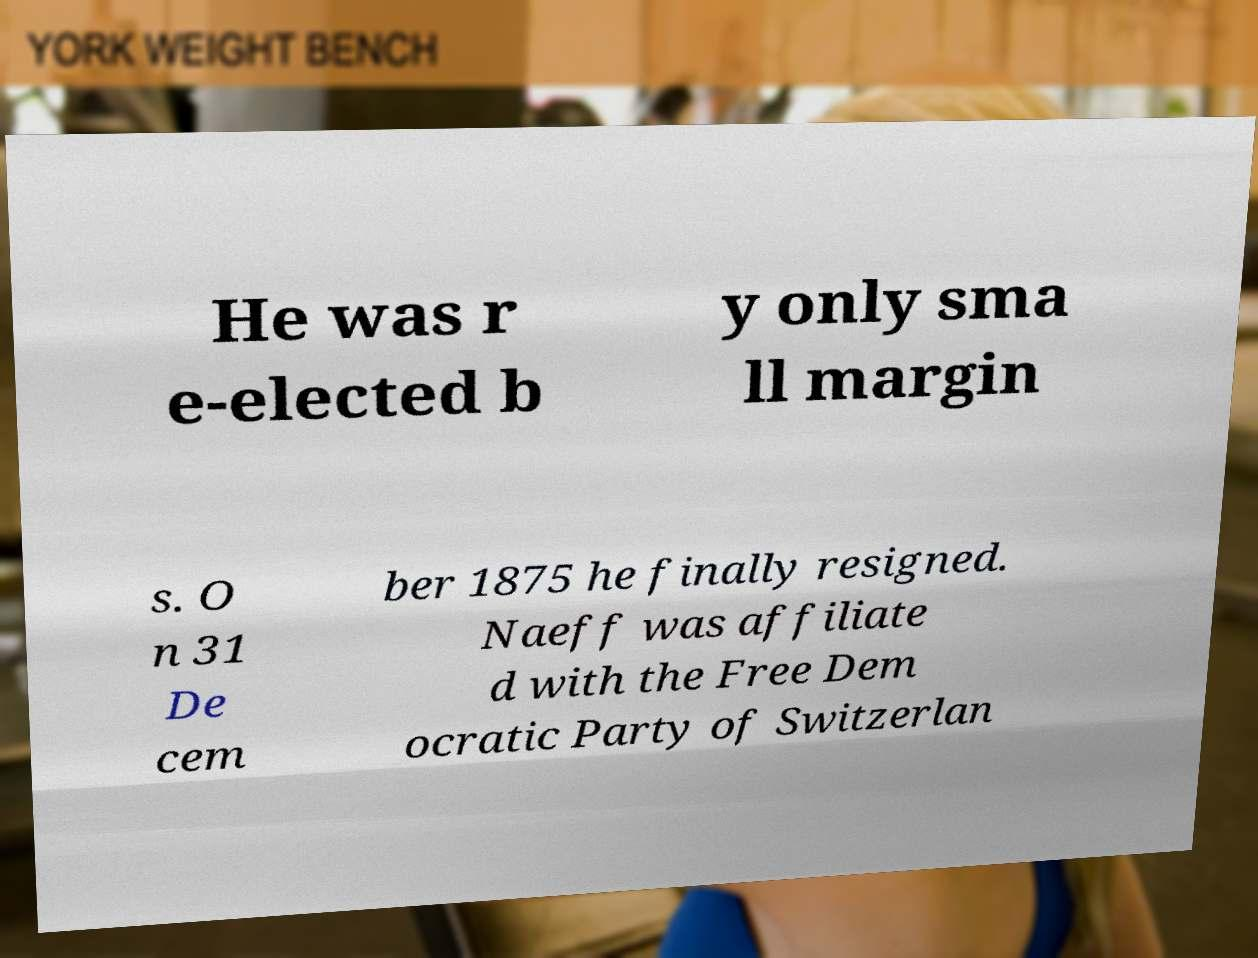Can you accurately transcribe the text from the provided image for me? He was r e-elected b y only sma ll margin s. O n 31 De cem ber 1875 he finally resigned. Naeff was affiliate d with the Free Dem ocratic Party of Switzerlan 